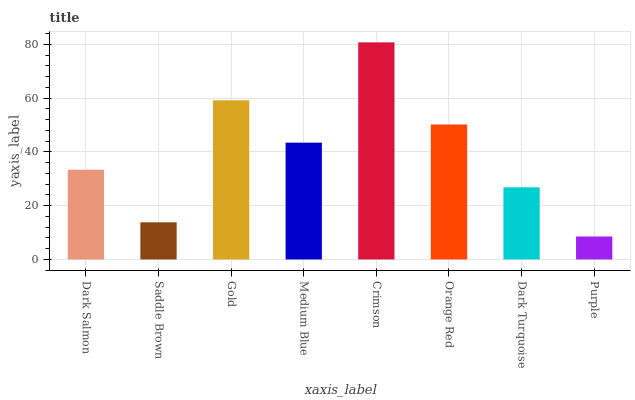Is Purple the minimum?
Answer yes or no. Yes. Is Crimson the maximum?
Answer yes or no. Yes. Is Saddle Brown the minimum?
Answer yes or no. No. Is Saddle Brown the maximum?
Answer yes or no. No. Is Dark Salmon greater than Saddle Brown?
Answer yes or no. Yes. Is Saddle Brown less than Dark Salmon?
Answer yes or no. Yes. Is Saddle Brown greater than Dark Salmon?
Answer yes or no. No. Is Dark Salmon less than Saddle Brown?
Answer yes or no. No. Is Medium Blue the high median?
Answer yes or no. Yes. Is Dark Salmon the low median?
Answer yes or no. Yes. Is Crimson the high median?
Answer yes or no. No. Is Gold the low median?
Answer yes or no. No. 